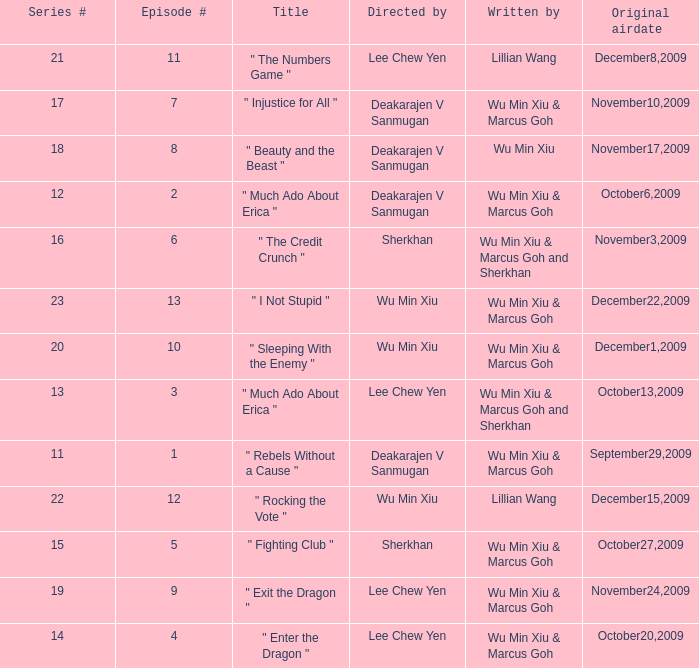What was the title for episode 2? " Much Ado About Erica ". 